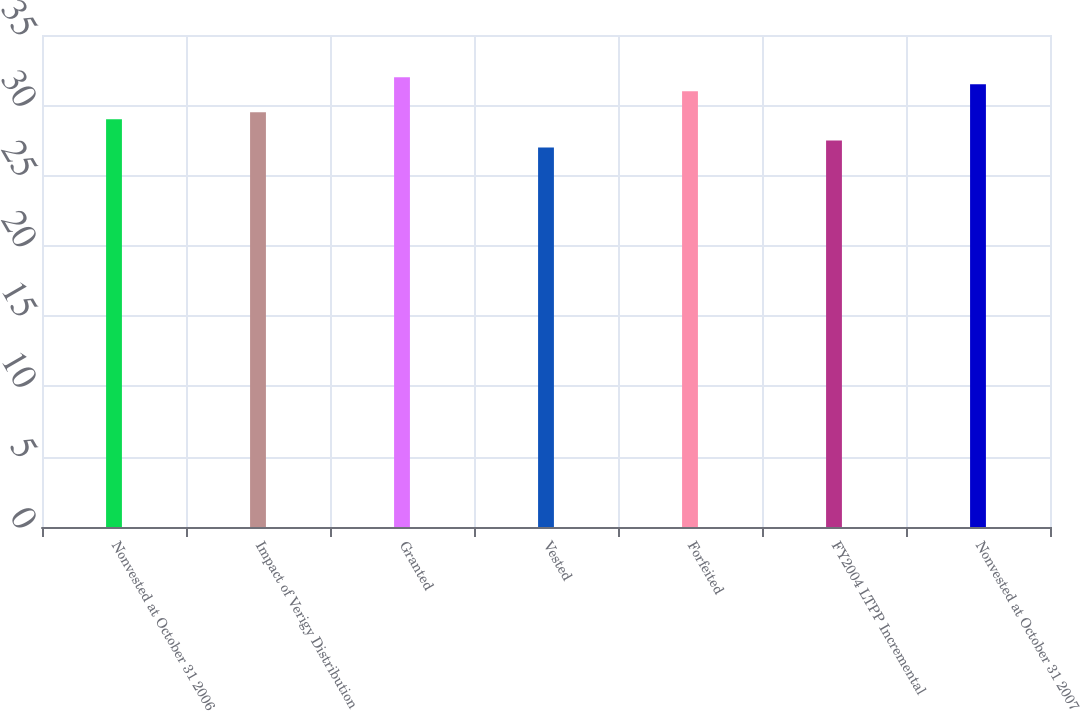<chart> <loc_0><loc_0><loc_500><loc_500><bar_chart><fcel>Nonvested at October 31 2006<fcel>Impact of Verigy Distribution<fcel>Granted<fcel>Vested<fcel>Forfeited<fcel>FY2004 LTPP Incremental<fcel>Nonvested at October 31 2007<nl><fcel>29<fcel>29.5<fcel>32<fcel>27<fcel>31<fcel>27.5<fcel>31.5<nl></chart> 